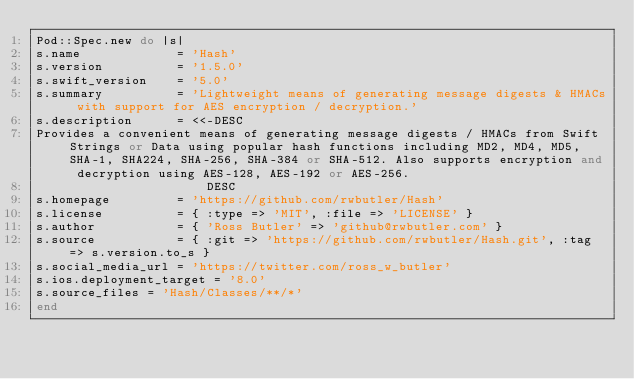<code> <loc_0><loc_0><loc_500><loc_500><_Ruby_>Pod::Spec.new do |s|
s.name             = 'Hash'
s.version          = '1.5.0'
s.swift_version    = '5.0'
s.summary          = 'Lightweight means of generating message digests & HMACs with support for AES encryption / decryption.'
s.description      = <<-DESC
Provides a convenient means of generating message digests / HMACs from Swift Strings or Data using popular hash functions including MD2, MD4, MD5, SHA-1, SHA224, SHA-256, SHA-384 or SHA-512. Also supports encryption and decryption using AES-128, AES-192 or AES-256.
                       DESC
s.homepage         = 'https://github.com/rwbutler/Hash'
s.license          = { :type => 'MIT', :file => 'LICENSE' }
s.author           = { 'Ross Butler' => 'github@rwbutler.com' }
s.source           = { :git => 'https://github.com/rwbutler/Hash.git', :tag => s.version.to_s }
s.social_media_url = 'https://twitter.com/ross_w_butler'
s.ios.deployment_target = '8.0'
s.source_files = 'Hash/Classes/**/*'
end
</code> 